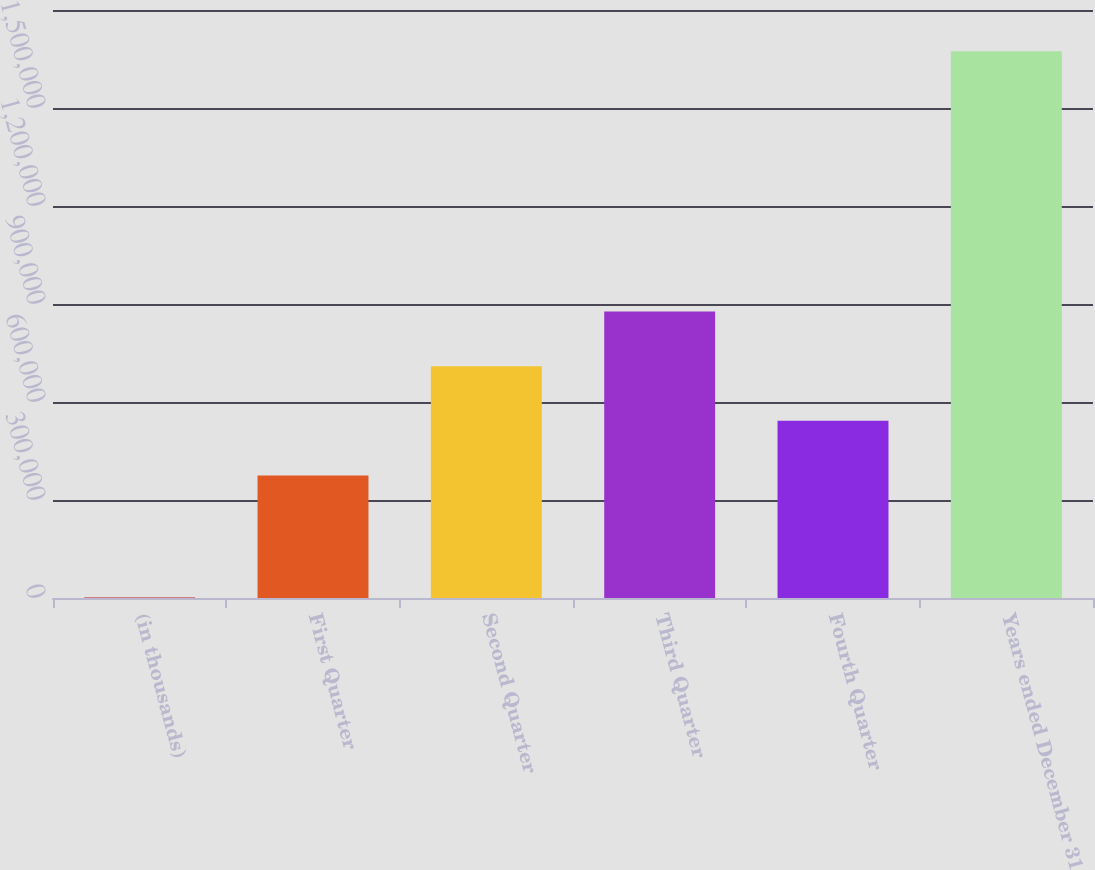Convert chart to OTSL. <chart><loc_0><loc_0><loc_500><loc_500><bar_chart><fcel>(in thousands)<fcel>First Quarter<fcel>Second Quarter<fcel>Third Quarter<fcel>Fourth Quarter<fcel>Years ended December 31<nl><fcel>2017<fcel>375247<fcel>709635<fcel>876829<fcel>542441<fcel>1.67396e+06<nl></chart> 